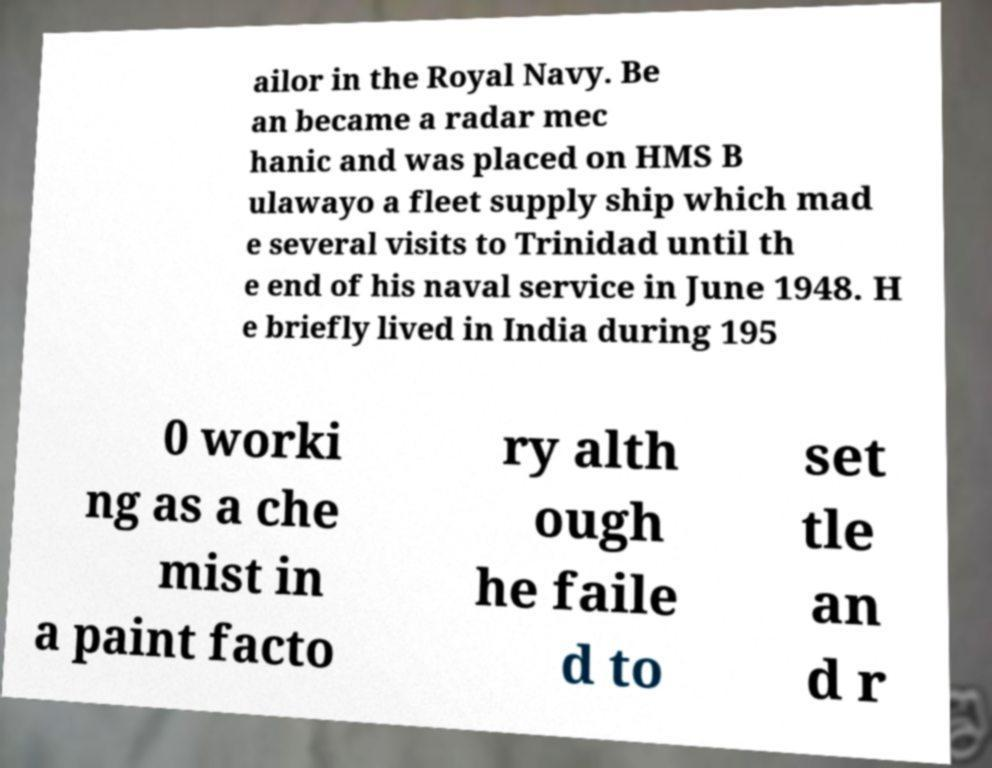I need the written content from this picture converted into text. Can you do that? ailor in the Royal Navy. Be an became a radar mec hanic and was placed on HMS B ulawayo a fleet supply ship which mad e several visits to Trinidad until th e end of his naval service in June 1948. H e briefly lived in India during 195 0 worki ng as a che mist in a paint facto ry alth ough he faile d to set tle an d r 